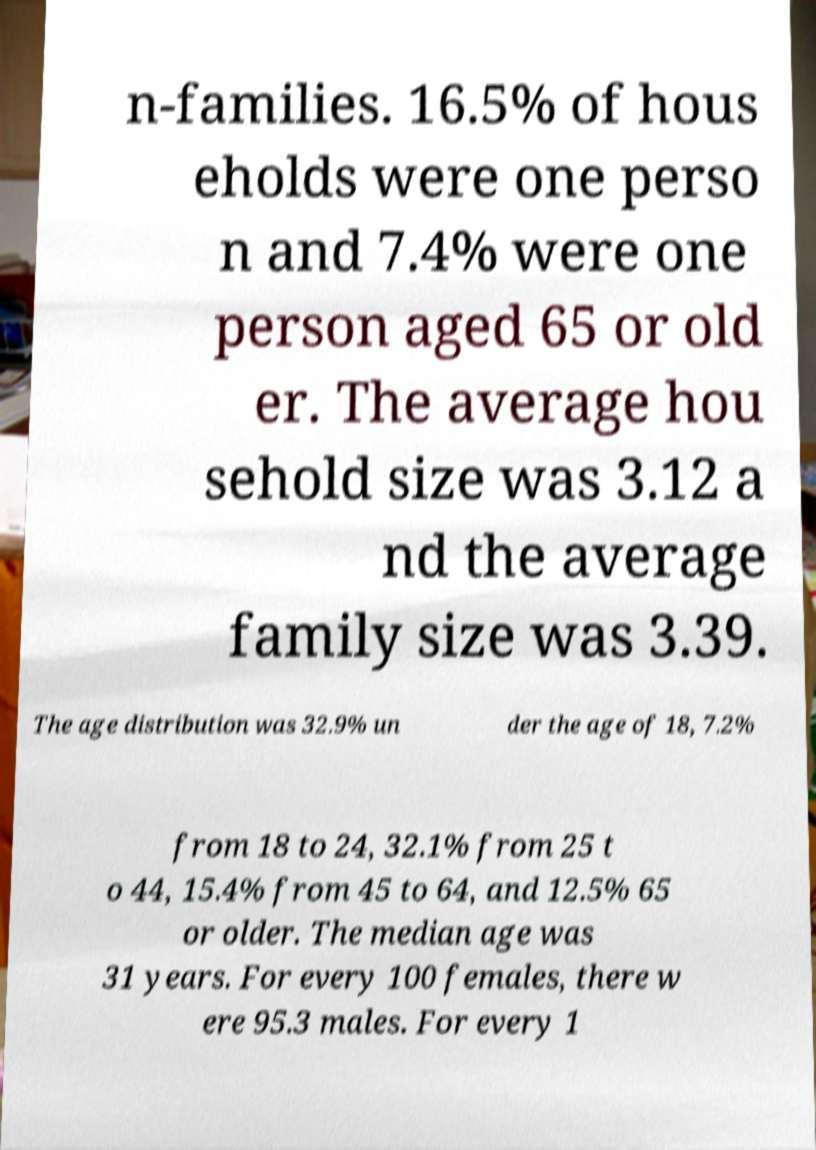Can you read and provide the text displayed in the image?This photo seems to have some interesting text. Can you extract and type it out for me? n-families. 16.5% of hous eholds were one perso n and 7.4% were one person aged 65 or old er. The average hou sehold size was 3.12 a nd the average family size was 3.39. The age distribution was 32.9% un der the age of 18, 7.2% from 18 to 24, 32.1% from 25 t o 44, 15.4% from 45 to 64, and 12.5% 65 or older. The median age was 31 years. For every 100 females, there w ere 95.3 males. For every 1 